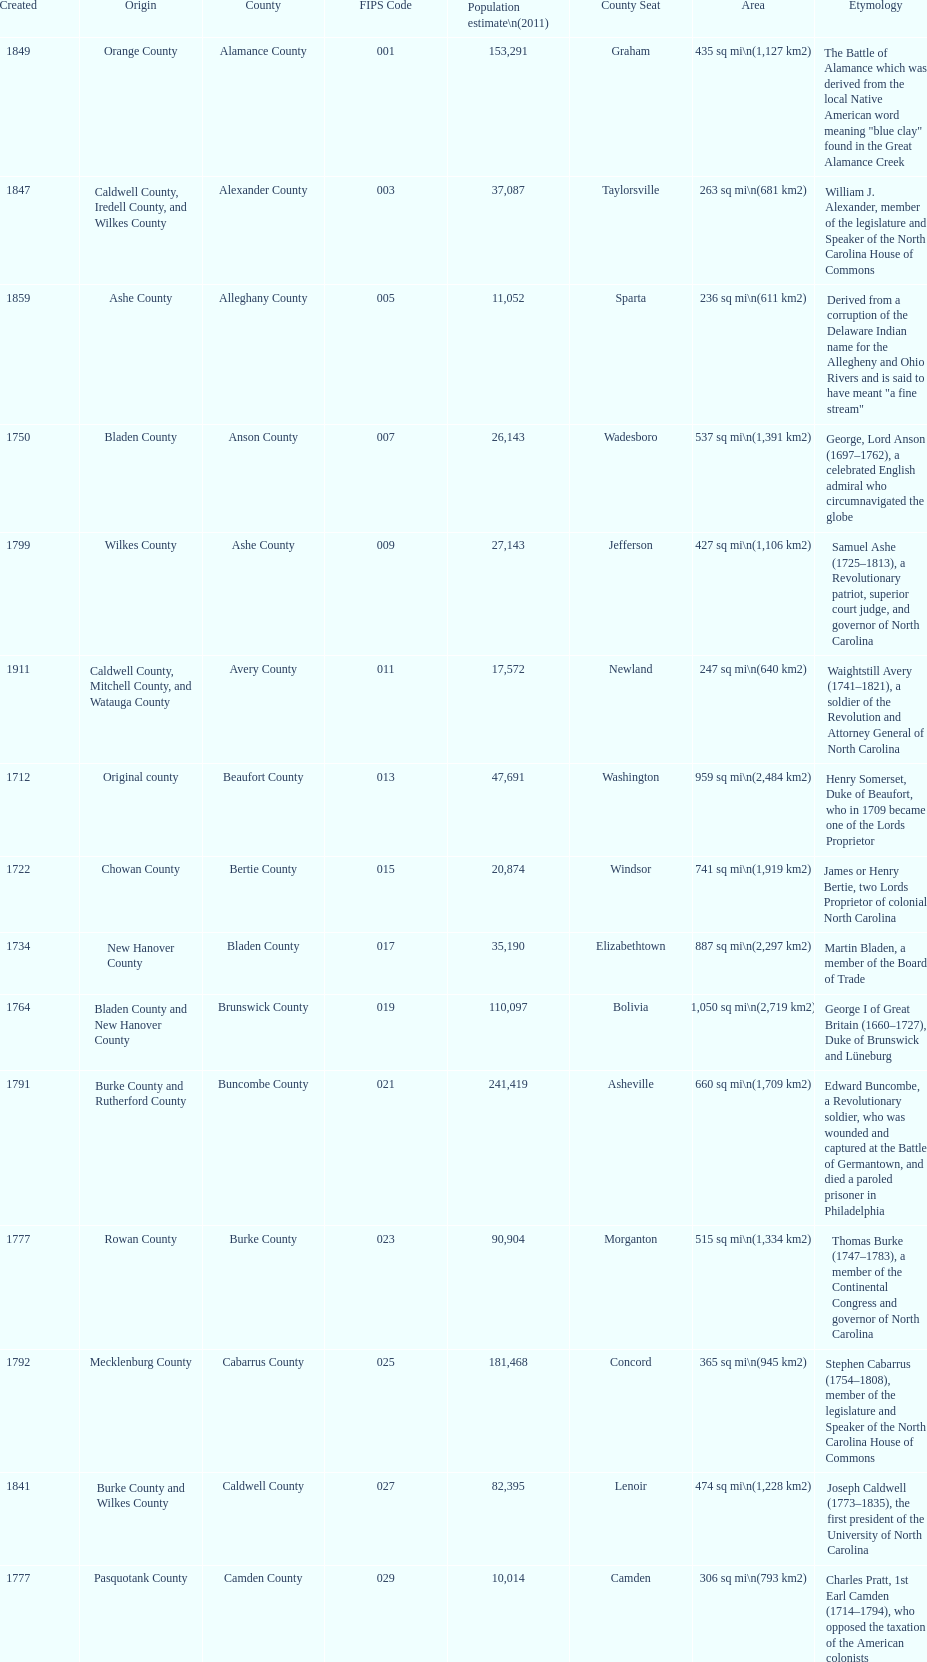Which county has a higher population, alamance or alexander? Alamance County. 